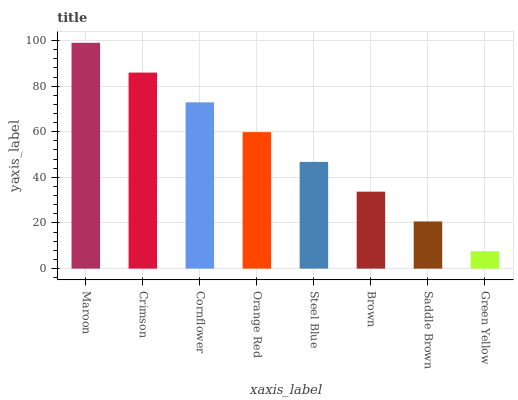Is Green Yellow the minimum?
Answer yes or no. Yes. Is Maroon the maximum?
Answer yes or no. Yes. Is Crimson the minimum?
Answer yes or no. No. Is Crimson the maximum?
Answer yes or no. No. Is Maroon greater than Crimson?
Answer yes or no. Yes. Is Crimson less than Maroon?
Answer yes or no. Yes. Is Crimson greater than Maroon?
Answer yes or no. No. Is Maroon less than Crimson?
Answer yes or no. No. Is Orange Red the high median?
Answer yes or no. Yes. Is Steel Blue the low median?
Answer yes or no. Yes. Is Cornflower the high median?
Answer yes or no. No. Is Brown the low median?
Answer yes or no. No. 